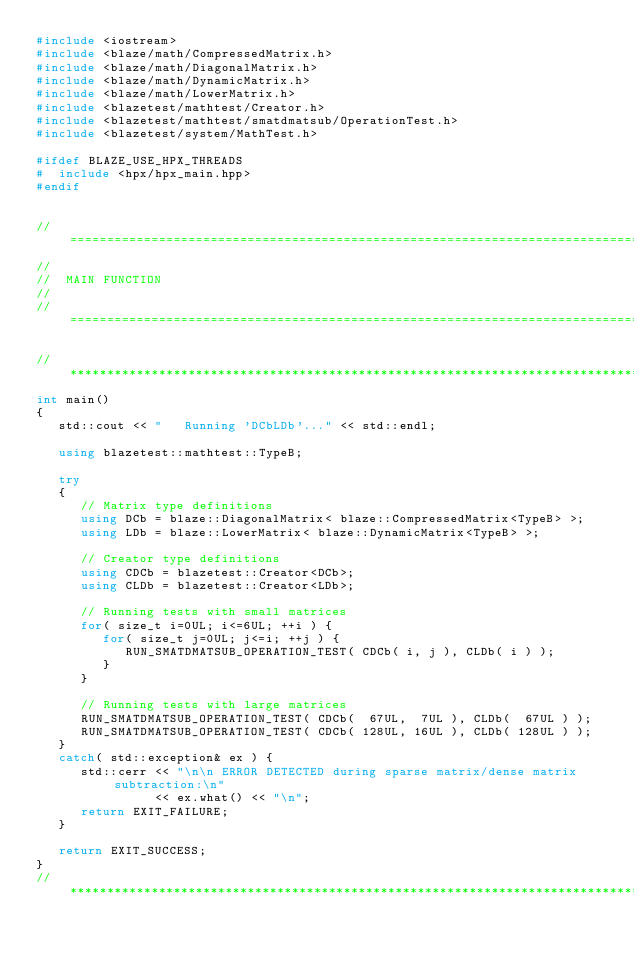<code> <loc_0><loc_0><loc_500><loc_500><_C++_>#include <iostream>
#include <blaze/math/CompressedMatrix.h>
#include <blaze/math/DiagonalMatrix.h>
#include <blaze/math/DynamicMatrix.h>
#include <blaze/math/LowerMatrix.h>
#include <blazetest/mathtest/Creator.h>
#include <blazetest/mathtest/smatdmatsub/OperationTest.h>
#include <blazetest/system/MathTest.h>

#ifdef BLAZE_USE_HPX_THREADS
#  include <hpx/hpx_main.hpp>
#endif


//=================================================================================================
//
//  MAIN FUNCTION
//
//=================================================================================================

//*************************************************************************************************
int main()
{
   std::cout << "   Running 'DCbLDb'..." << std::endl;

   using blazetest::mathtest::TypeB;

   try
   {
      // Matrix type definitions
      using DCb = blaze::DiagonalMatrix< blaze::CompressedMatrix<TypeB> >;
      using LDb = blaze::LowerMatrix< blaze::DynamicMatrix<TypeB> >;

      // Creator type definitions
      using CDCb = blazetest::Creator<DCb>;
      using CLDb = blazetest::Creator<LDb>;

      // Running tests with small matrices
      for( size_t i=0UL; i<=6UL; ++i ) {
         for( size_t j=0UL; j<=i; ++j ) {
            RUN_SMATDMATSUB_OPERATION_TEST( CDCb( i, j ), CLDb( i ) );
         }
      }

      // Running tests with large matrices
      RUN_SMATDMATSUB_OPERATION_TEST( CDCb(  67UL,  7UL ), CLDb(  67UL ) );
      RUN_SMATDMATSUB_OPERATION_TEST( CDCb( 128UL, 16UL ), CLDb( 128UL ) );
   }
   catch( std::exception& ex ) {
      std::cerr << "\n\n ERROR DETECTED during sparse matrix/dense matrix subtraction:\n"
                << ex.what() << "\n";
      return EXIT_FAILURE;
   }

   return EXIT_SUCCESS;
}
//*************************************************************************************************
</code> 